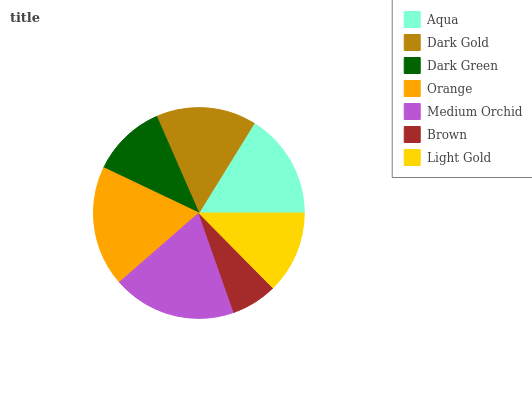Is Brown the minimum?
Answer yes or no. Yes. Is Medium Orchid the maximum?
Answer yes or no. Yes. Is Dark Gold the minimum?
Answer yes or no. No. Is Dark Gold the maximum?
Answer yes or no. No. Is Aqua greater than Dark Gold?
Answer yes or no. Yes. Is Dark Gold less than Aqua?
Answer yes or no. Yes. Is Dark Gold greater than Aqua?
Answer yes or no. No. Is Aqua less than Dark Gold?
Answer yes or no. No. Is Dark Gold the high median?
Answer yes or no. Yes. Is Dark Gold the low median?
Answer yes or no. Yes. Is Orange the high median?
Answer yes or no. No. Is Brown the low median?
Answer yes or no. No. 